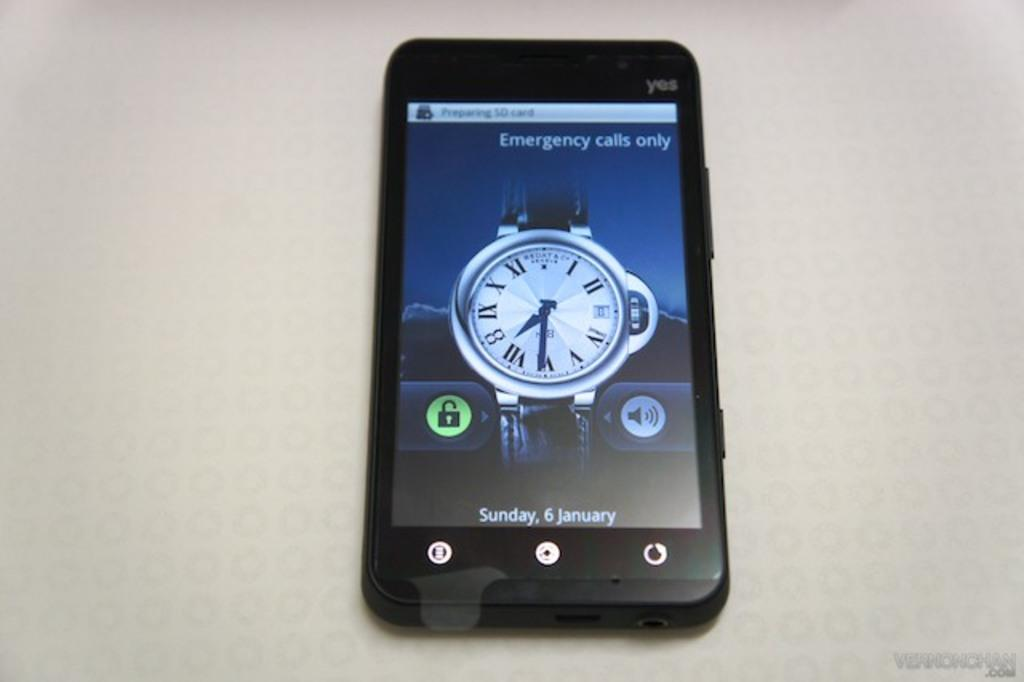What object is present in the image? There is a mobile in the image. What is the color of the surface the mobile is on? The mobile is on a white surface. What can be seen on the screen of the mobile? There are icons visible on the screen of the mobile, including a watch image. How many additions were made to the mobile during the war? There is no mention of additions, war, or any historical context in the image. The image only shows a mobile with a watch icon on its screen. 